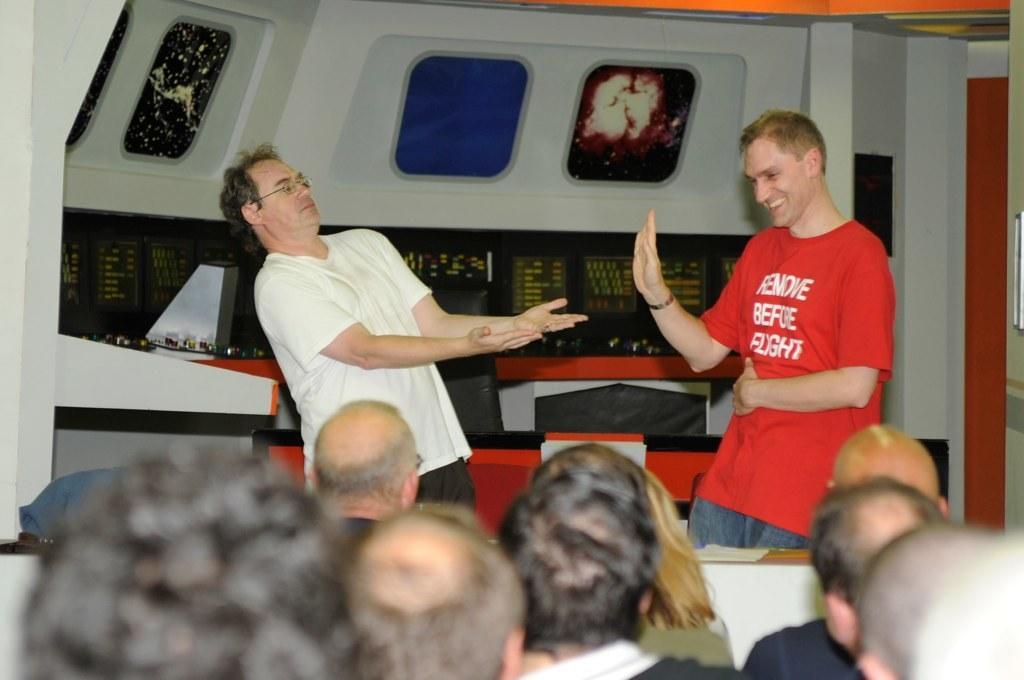Please provide a concise description of this image. In this image, we can see people and some are wearing glasses. In the background, there are some objects and we can see some text on the boards and there are some stands. 